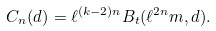Convert formula to latex. <formula><loc_0><loc_0><loc_500><loc_500>C _ { n } ( d ) = \ell ^ { ( k - 2 ) n } B _ { t } ( \ell ^ { 2 n } m , d ) .</formula> 